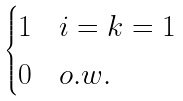Convert formula to latex. <formula><loc_0><loc_0><loc_500><loc_500>\begin{cases} 1 & i = k = 1 \\ 0 & o . w . \\ \end{cases}</formula> 